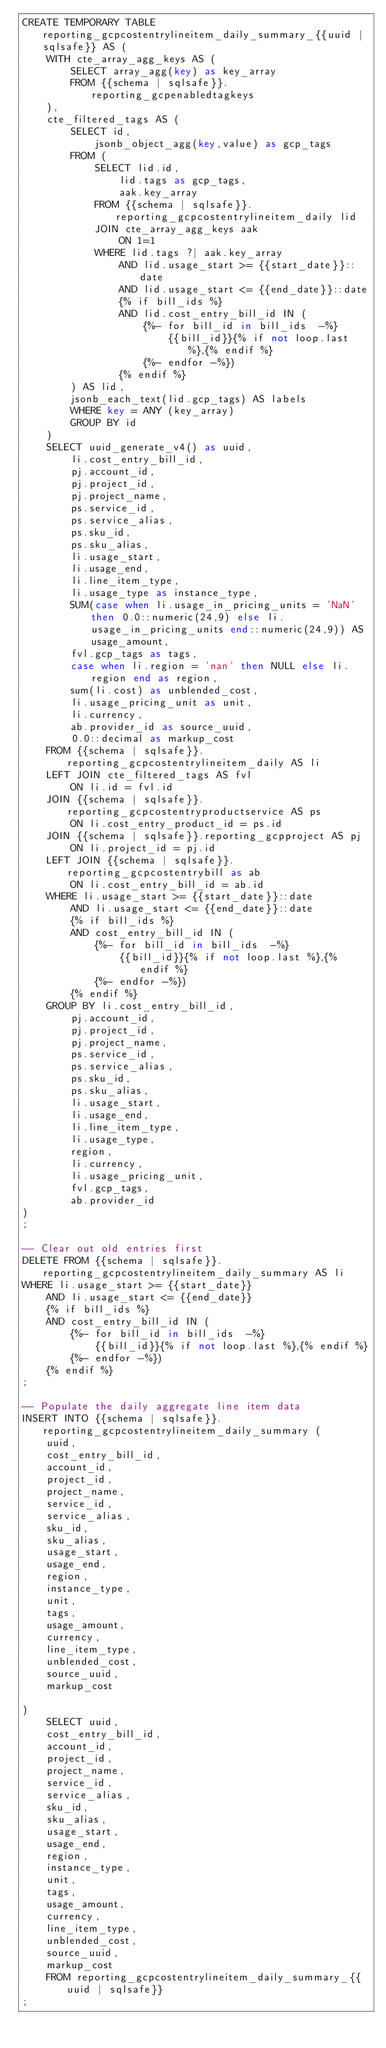<code> <loc_0><loc_0><loc_500><loc_500><_SQL_>CREATE TEMPORARY TABLE reporting_gcpcostentrylineitem_daily_summary_{{uuid | sqlsafe}} AS (
    WITH cte_array_agg_keys AS (
        SELECT array_agg(key) as key_array
        FROM {{schema | sqlsafe}}.reporting_gcpenabledtagkeys
    ),
    cte_filtered_tags AS (
        SELECT id,
            jsonb_object_agg(key,value) as gcp_tags
        FROM (
            SELECT lid.id,
                lid.tags as gcp_tags,
                aak.key_array
            FROM {{schema | sqlsafe}}.reporting_gcpcostentrylineitem_daily lid
            JOIN cte_array_agg_keys aak
                ON 1=1
            WHERE lid.tags ?| aak.key_array
                AND lid.usage_start >= {{start_date}}::date
                AND lid.usage_start <= {{end_date}}::date
                {% if bill_ids %}
                AND lid.cost_entry_bill_id IN (
                    {%- for bill_id in bill_ids  -%}
                        {{bill_id}}{% if not loop.last %},{% endif %}
                    {%- endfor -%})
                {% endif %}
        ) AS lid,
        jsonb_each_text(lid.gcp_tags) AS labels
        WHERE key = ANY (key_array)
        GROUP BY id
    )
    SELECT uuid_generate_v4() as uuid,
        li.cost_entry_bill_id,
        pj.account_id,
        pj.project_id,
        pj.project_name,
        ps.service_id,
        ps.service_alias,
        ps.sku_id,
        ps.sku_alias,
        li.usage_start,
        li.usage_end,
        li.line_item_type,
        li.usage_type as instance_type,
        SUM(case when li.usage_in_pricing_units = 'NaN' then 0.0::numeric(24,9) else li.usage_in_pricing_units end::numeric(24,9)) AS usage_amount,
        fvl.gcp_tags as tags,
        case when li.region = 'nan' then NULL else li.region end as region,
        sum(li.cost) as unblended_cost,
        li.usage_pricing_unit as unit,
        li.currency,
        ab.provider_id as source_uuid,
        0.0::decimal as markup_cost
    FROM {{schema | sqlsafe}}.reporting_gcpcostentrylineitem_daily AS li
    LEFT JOIN cte_filtered_tags AS fvl
        ON li.id = fvl.id
    JOIN {{schema | sqlsafe}}.reporting_gcpcostentryproductservice AS ps
        ON li.cost_entry_product_id = ps.id
    JOIN {{schema | sqlsafe}}.reporting_gcpproject AS pj
        ON li.project_id = pj.id
    LEFT JOIN {{schema | sqlsafe}}.reporting_gcpcostentrybill as ab
        ON li.cost_entry_bill_id = ab.id
    WHERE li.usage_start >= {{start_date}}::date
        AND li.usage_start <= {{end_date}}::date
        {% if bill_ids %}
        AND cost_entry_bill_id IN (
            {%- for bill_id in bill_ids  -%}
                {{bill_id}}{% if not loop.last %},{% endif %}
            {%- endfor -%})
        {% endif %}
    GROUP BY li.cost_entry_bill_id,
        pj.account_id,
        pj.project_id,
        pj.project_name,
        ps.service_id,
        ps.service_alias,
        ps.sku_id,
        ps.sku_alias,
        li.usage_start,
        li.usage_end,
        li.line_item_type,
        li.usage_type,
        region,
        li.currency,
        li.usage_pricing_unit,
        fvl.gcp_tags,
        ab.provider_id
)
;

-- Clear out old entries first
DELETE FROM {{schema | sqlsafe}}.reporting_gcpcostentrylineitem_daily_summary AS li
WHERE li.usage_start >= {{start_date}}
    AND li.usage_start <= {{end_date}}
    {% if bill_ids %}
    AND cost_entry_bill_id IN (
        {%- for bill_id in bill_ids  -%}
            {{bill_id}}{% if not loop.last %},{% endif %}
        {%- endfor -%})
    {% endif %}
;

-- Populate the daily aggregate line item data
INSERT INTO {{schema | sqlsafe}}.reporting_gcpcostentrylineitem_daily_summary (
    uuid,
    cost_entry_bill_id,
    account_id,
    project_id,
    project_name,
    service_id,
    service_alias,
    sku_id,
    sku_alias,
    usage_start,
    usage_end,
    region,
    instance_type,
    unit,
    tags,
    usage_amount,
    currency,
    line_item_type,
    unblended_cost,
    source_uuid,
    markup_cost

)
    SELECT uuid,
    cost_entry_bill_id,
    account_id,
    project_id,
    project_name,
    service_id,
    service_alias,
    sku_id,
    sku_alias,
    usage_start,
    usage_end,
    region,
    instance_type,
    unit,
    tags,
    usage_amount,
    currency,
    line_item_type,
    unblended_cost,
    source_uuid,
    markup_cost
    FROM reporting_gcpcostentrylineitem_daily_summary_{{uuid | sqlsafe}}
;
</code> 